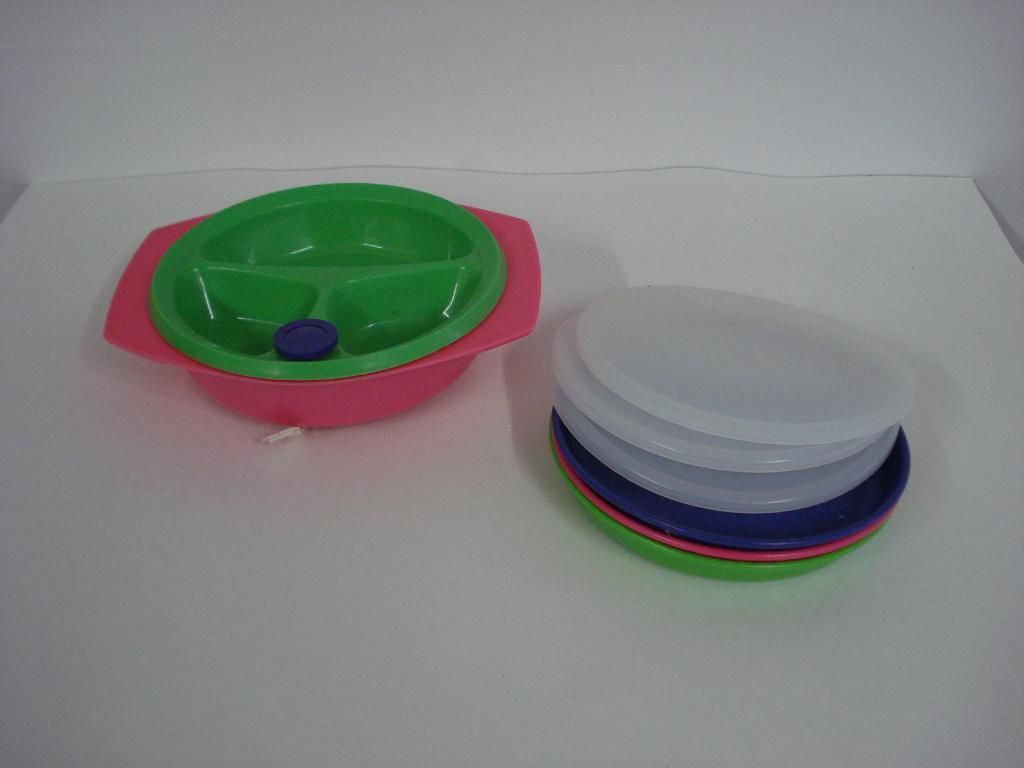What is the main object in the image that resembles a piece of furniture? There is an object that looks like a table in the image. What is placed on the table? There are objects on the table. What can be seen in the background of the image? There is a wall visible in the image. What type of fear can be seen on the faces of the people in the image? There are no people present in the image, so it is not possible to determine if they are experiencing any fear. 